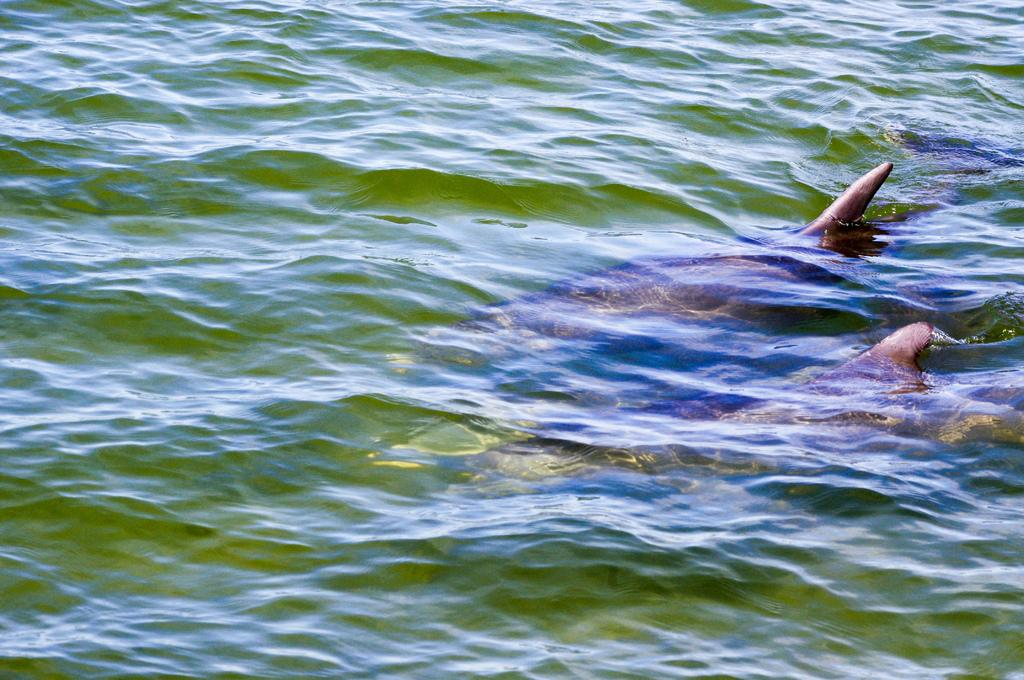What is the primary element visible in the image? There is water in the image. What type of animal can be seen in the water? There appears to be a dolphin in the water. What is the value of the plough in the image? There is no plough present in the image, so it is not possible to determine its value. 